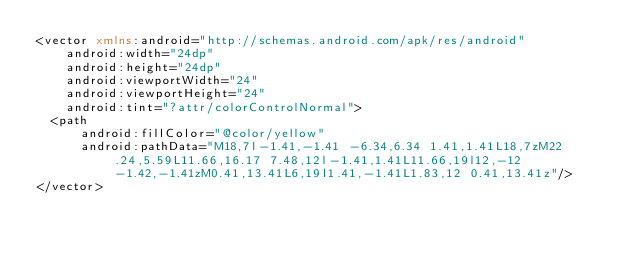<code> <loc_0><loc_0><loc_500><loc_500><_XML_><vector xmlns:android="http://schemas.android.com/apk/res/android"
    android:width="24dp"
    android:height="24dp"
    android:viewportWidth="24"
    android:viewportHeight="24"
    android:tint="?attr/colorControlNormal">
  <path
      android:fillColor="@color/yellow"
      android:pathData="M18,7l-1.41,-1.41 -6.34,6.34 1.41,1.41L18,7zM22.24,5.59L11.66,16.17 7.48,12l-1.41,1.41L11.66,19l12,-12 -1.42,-1.41zM0.41,13.41L6,19l1.41,-1.41L1.83,12 0.41,13.41z"/>
</vector>
</code> 